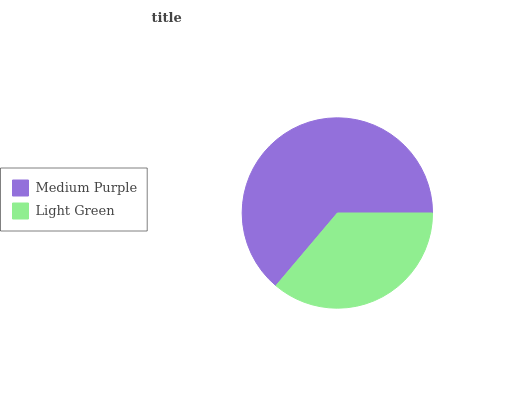Is Light Green the minimum?
Answer yes or no. Yes. Is Medium Purple the maximum?
Answer yes or no. Yes. Is Light Green the maximum?
Answer yes or no. No. Is Medium Purple greater than Light Green?
Answer yes or no. Yes. Is Light Green less than Medium Purple?
Answer yes or no. Yes. Is Light Green greater than Medium Purple?
Answer yes or no. No. Is Medium Purple less than Light Green?
Answer yes or no. No. Is Medium Purple the high median?
Answer yes or no. Yes. Is Light Green the low median?
Answer yes or no. Yes. Is Light Green the high median?
Answer yes or no. No. Is Medium Purple the low median?
Answer yes or no. No. 